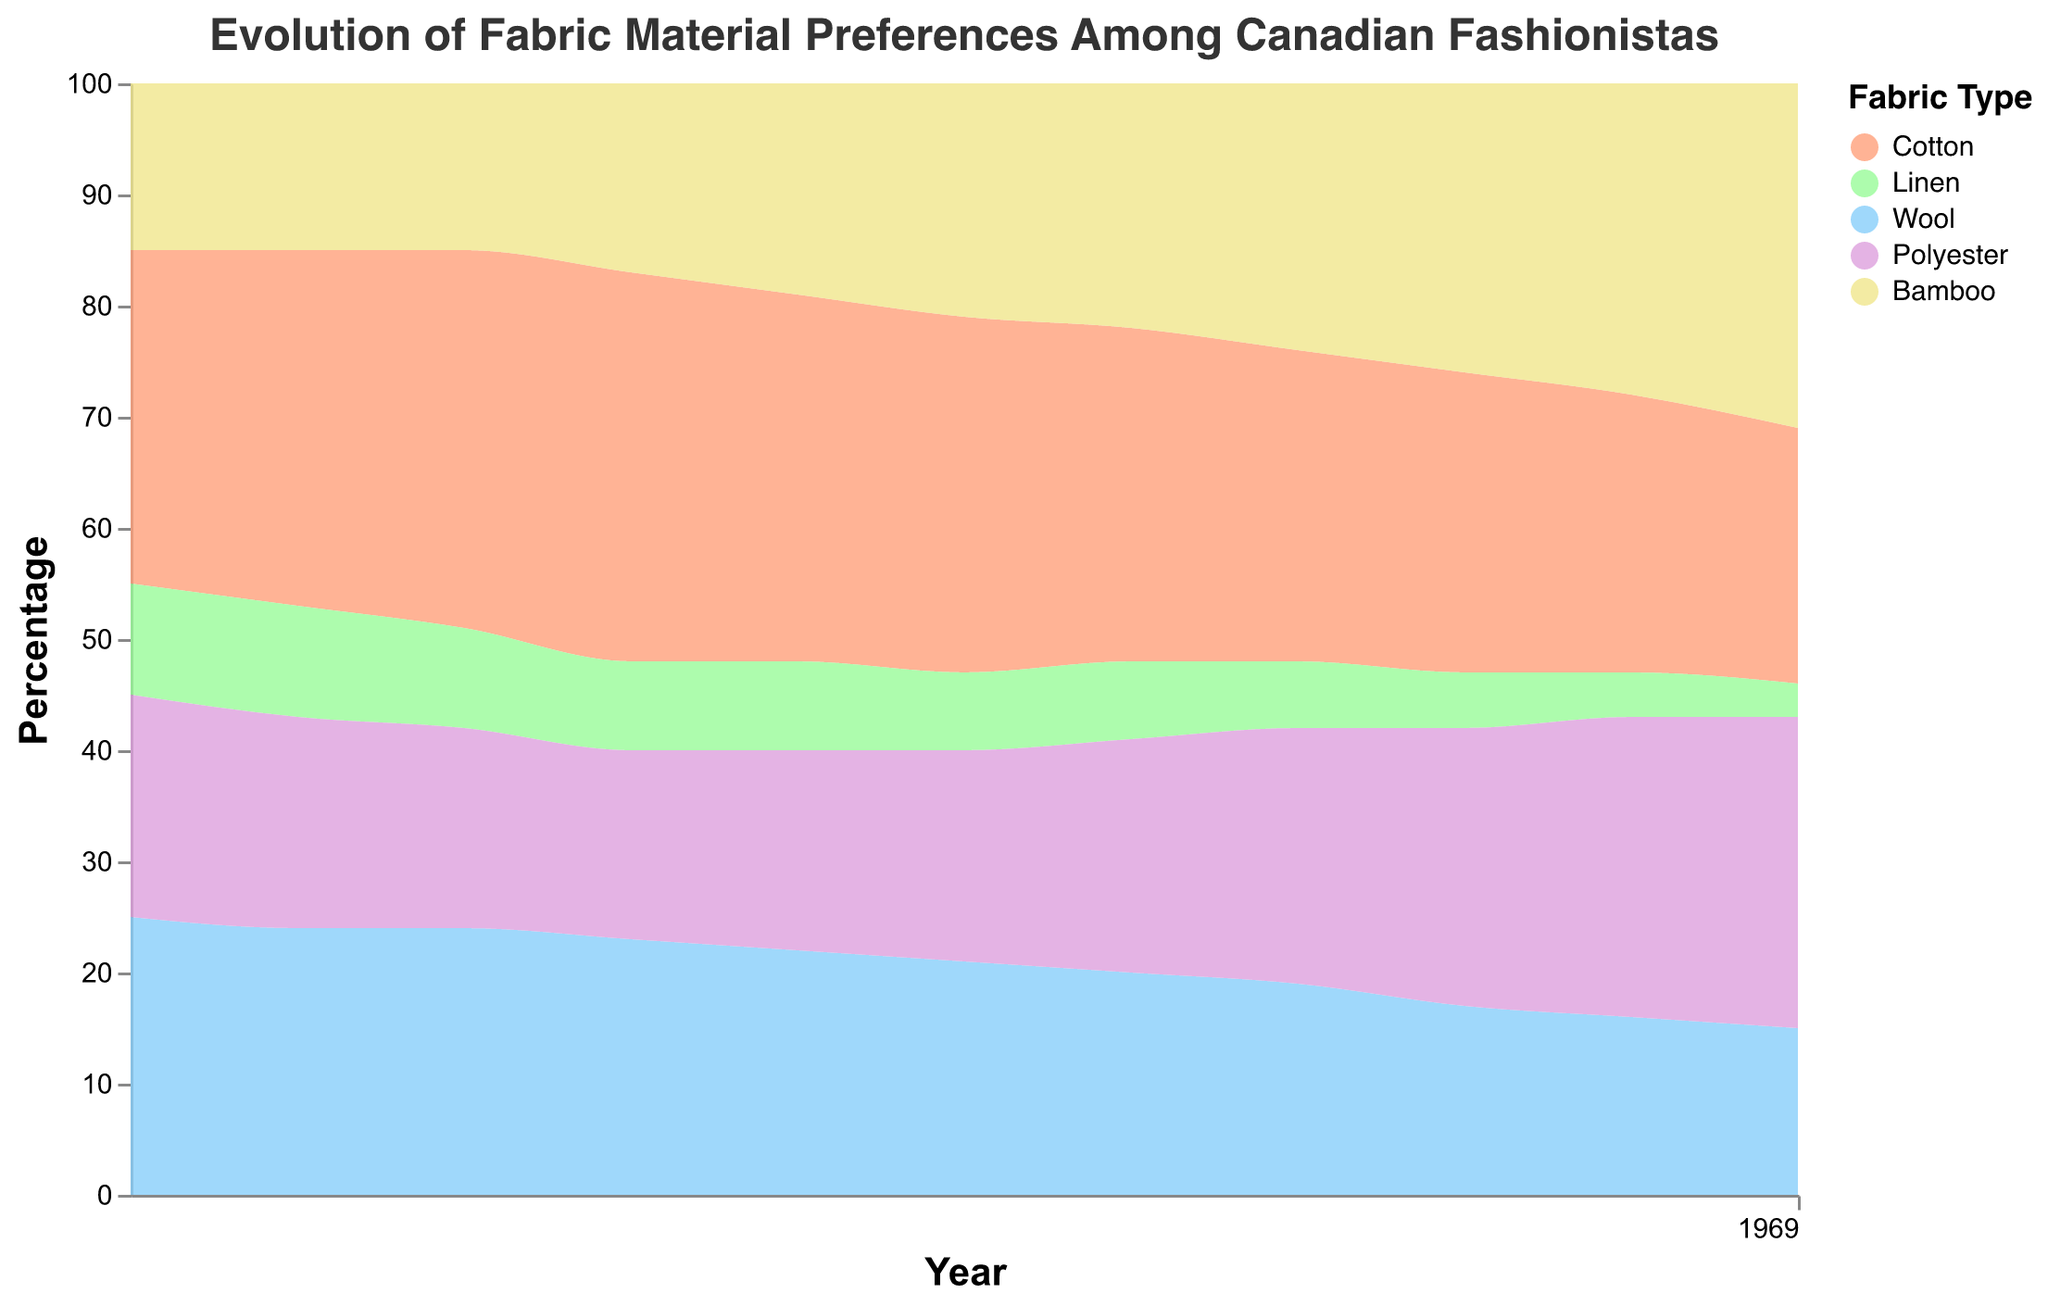What is the title of the figure? The title is displayed at the top center of the figure and reads, "Evolution of Fabric Material Preferences Among Canadian Fashionistas."
Answer: Evolution of Fabric Material Preferences Among Canadian Fashionistas What does the x-axis represent? The x-axis is labeled "Year" and shows the temporal progression of data from 2013 to 2023.
Answer: Year Which fabric type had the highest percentage in 2013? By looking at the stream graph for the year 2013, the fabric with the widest band is Cotton, which had the highest percentage.
Answer: Cotton How did the percentage of Polyester change from 2013 to 2023? Observe the thickness of the Polyester band from the start to the end. In 2013, it was at 20%, and by 2023, it reached 28%. The percentage increased by 8%.
Answer: Increased What is the trend for Bamboo fabric over the ten-year period? Bamboo's band starts at 15% in 2013 and gradually widens to 31% in 2023, indicating a consistent upward trend over the years.
Answer: Upward Which fabric type had the largest decrease in preference from 2013 to 2023? Compare all the bands. Cotton starts at 30% in 2013 and decreases to 23% in 2023, showing a decrease of 7%. Linen also decreased, but only by 7 percentage points from 10% to 3%.
Answer: Cotton By how much did the percentage of Linen decrease from 2013 to 2023? Look at the Linen stream band and compare its value in 2013 (10%) to its value in 2023 (3%). It decreased by 7%.
Answer: 7% Which fabric had the highest percentage in 2023, and what was it? Look at the end of the timeline in 2023. Bamboo has the thickest band, representing the highest percentage at 31%.
Answer: Bamboo, 31% Which two fabric types had nearly constant percentages from 2013 to 2015? Looking at the bands, Linen maintained 10% (slightly decreased) and Bamboo remained at 15% across these years.
Answer: Linen and Bamboo Compare the trends of Wool and Polyester from 2020 to 2023. In 2020, Wool starts at 19% and decreases to 15% by 2023. Polyester starts at 23% in 2020 and increases to 28% by 2023.
Answer: Wool decreased, Polyester increased 